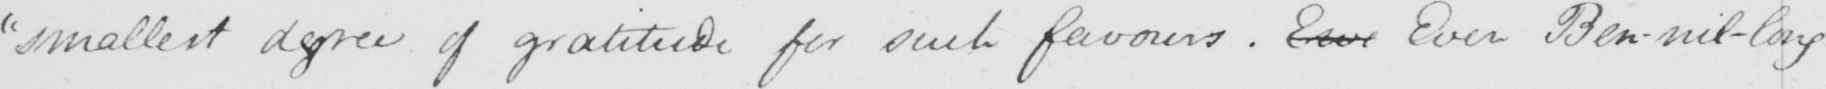What does this handwritten line say? "smallest degree of gratitude for such favours. Even Even Ben-nil-long 